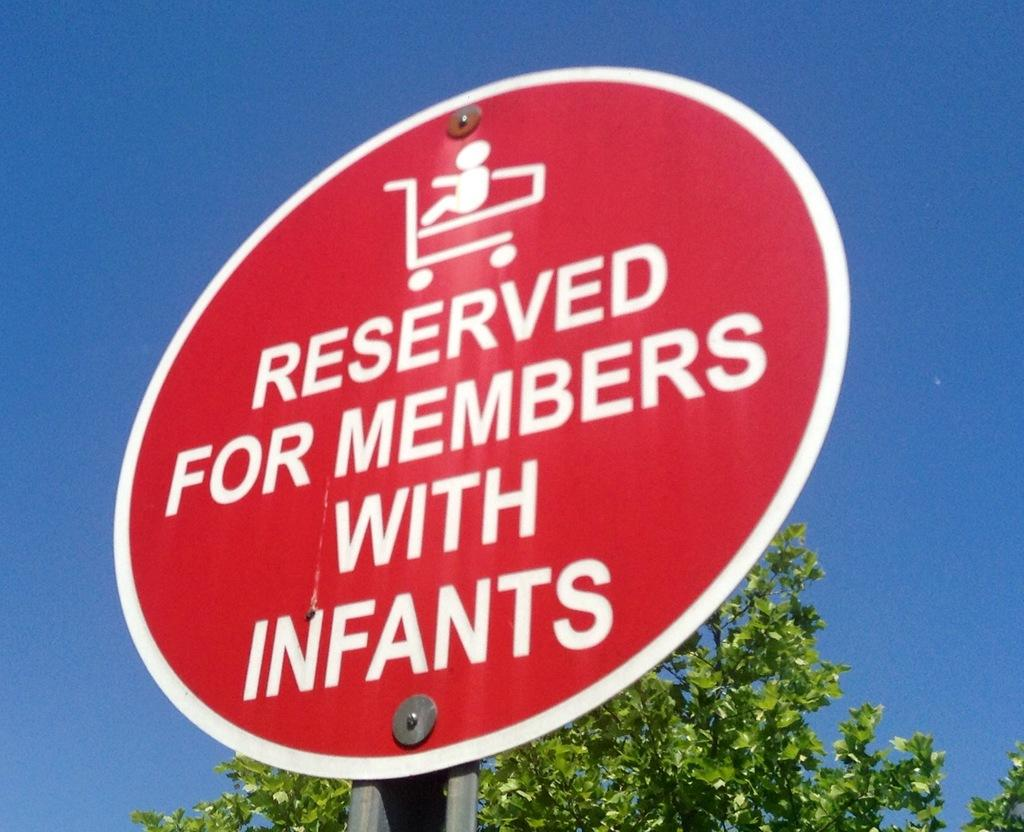<image>
Present a compact description of the photo's key features. The red sign explains that it is reserved for members with infants. 